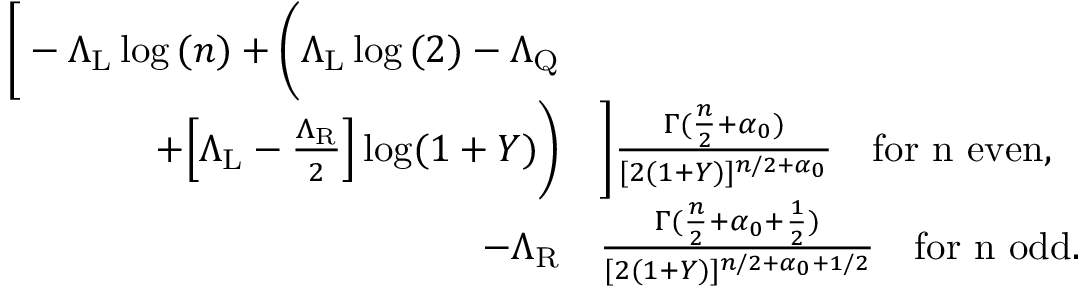<formula> <loc_0><loc_0><loc_500><loc_500>\begin{array} { r l } { \left [ - \Lambda _ { L } \log { ( n ) } + \left ( \Lambda _ { L } \log { ( 2 ) } - \Lambda _ { Q } } \\ { + \left [ \Lambda _ { L } - \frac { \Lambda _ { R } } { 2 } \right ] \log ( 1 + Y ) \right ) } & { \right ] \frac { \Gamma ( \frac { n } { 2 } + \alpha _ { 0 } ) } { [ 2 ( 1 + Y ) ] ^ { n / 2 + \alpha _ { 0 } } } \quad f o r n e v e n , } \\ { - \Lambda _ { R } } & { \frac { \Gamma ( \frac { n } { 2 } + { \alpha _ { 0 } + \frac { 1 } { 2 } } ) } { [ 2 ( 1 + Y ) ] ^ { n / 2 + { \alpha _ { 0 } + 1 / 2 } } } \quad f o r n o d d . } \end{array}</formula> 